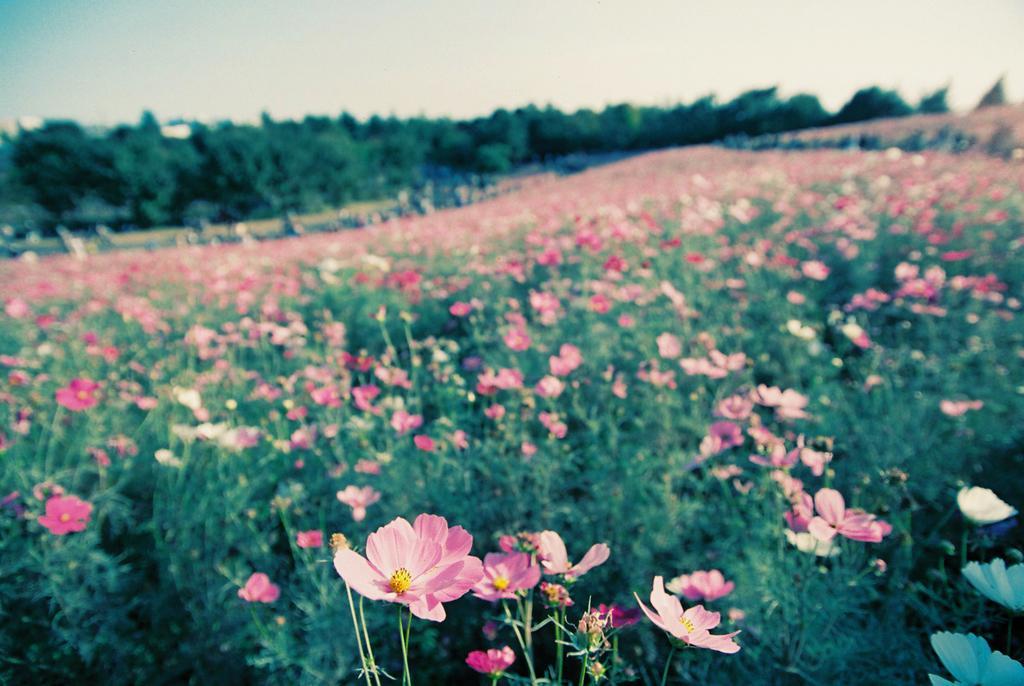Can you describe this image briefly? These are the beautiful flowers garden, in the middle there are trees. At the top it is the sky. 